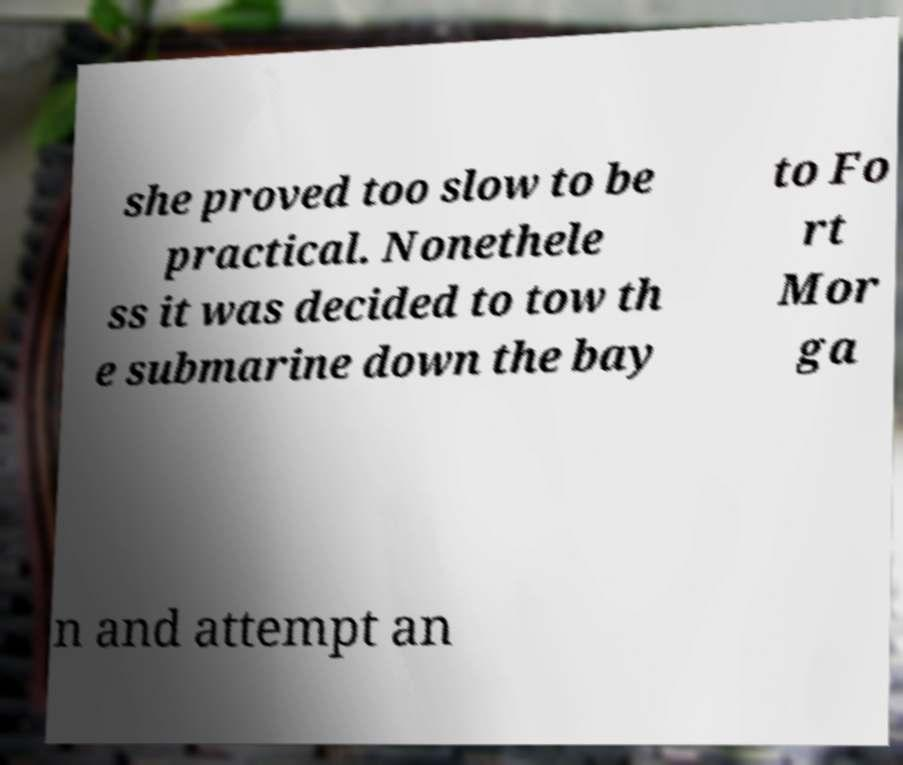Please read and relay the text visible in this image. What does it say? she proved too slow to be practical. Nonethele ss it was decided to tow th e submarine down the bay to Fo rt Mor ga n and attempt an 